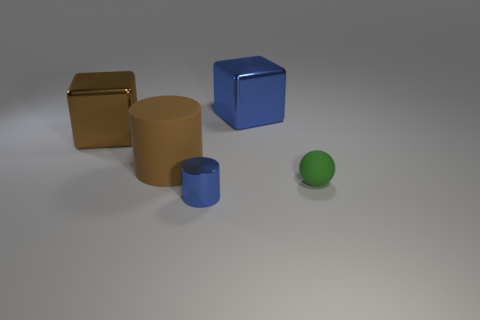Add 3 small shiny things. How many objects exist? 8 Subtract all brown cylinders. How many cylinders are left? 1 Subtract 1 green balls. How many objects are left? 4 Subtract all cubes. How many objects are left? 3 Subtract 1 balls. How many balls are left? 0 Subtract all gray balls. Subtract all blue cylinders. How many balls are left? 1 Subtract all red balls. How many brown cubes are left? 1 Subtract all matte cylinders. Subtract all large cyan matte things. How many objects are left? 4 Add 4 large blocks. How many large blocks are left? 6 Add 5 small red matte blocks. How many small red matte blocks exist? 5 